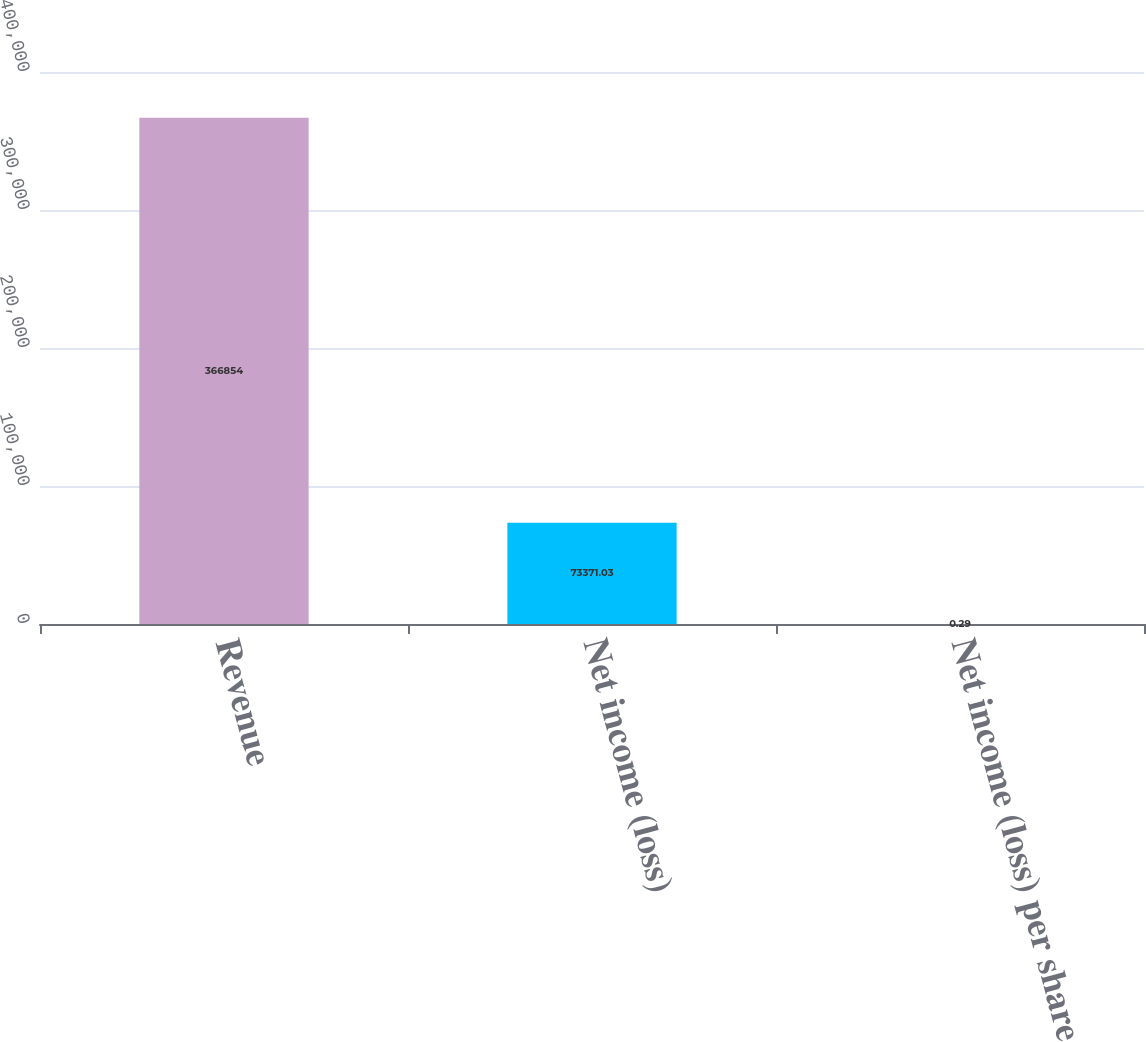Convert chart. <chart><loc_0><loc_0><loc_500><loc_500><bar_chart><fcel>Revenue<fcel>Net income (loss)<fcel>Net income (loss) per share<nl><fcel>366854<fcel>73371<fcel>0.29<nl></chart> 